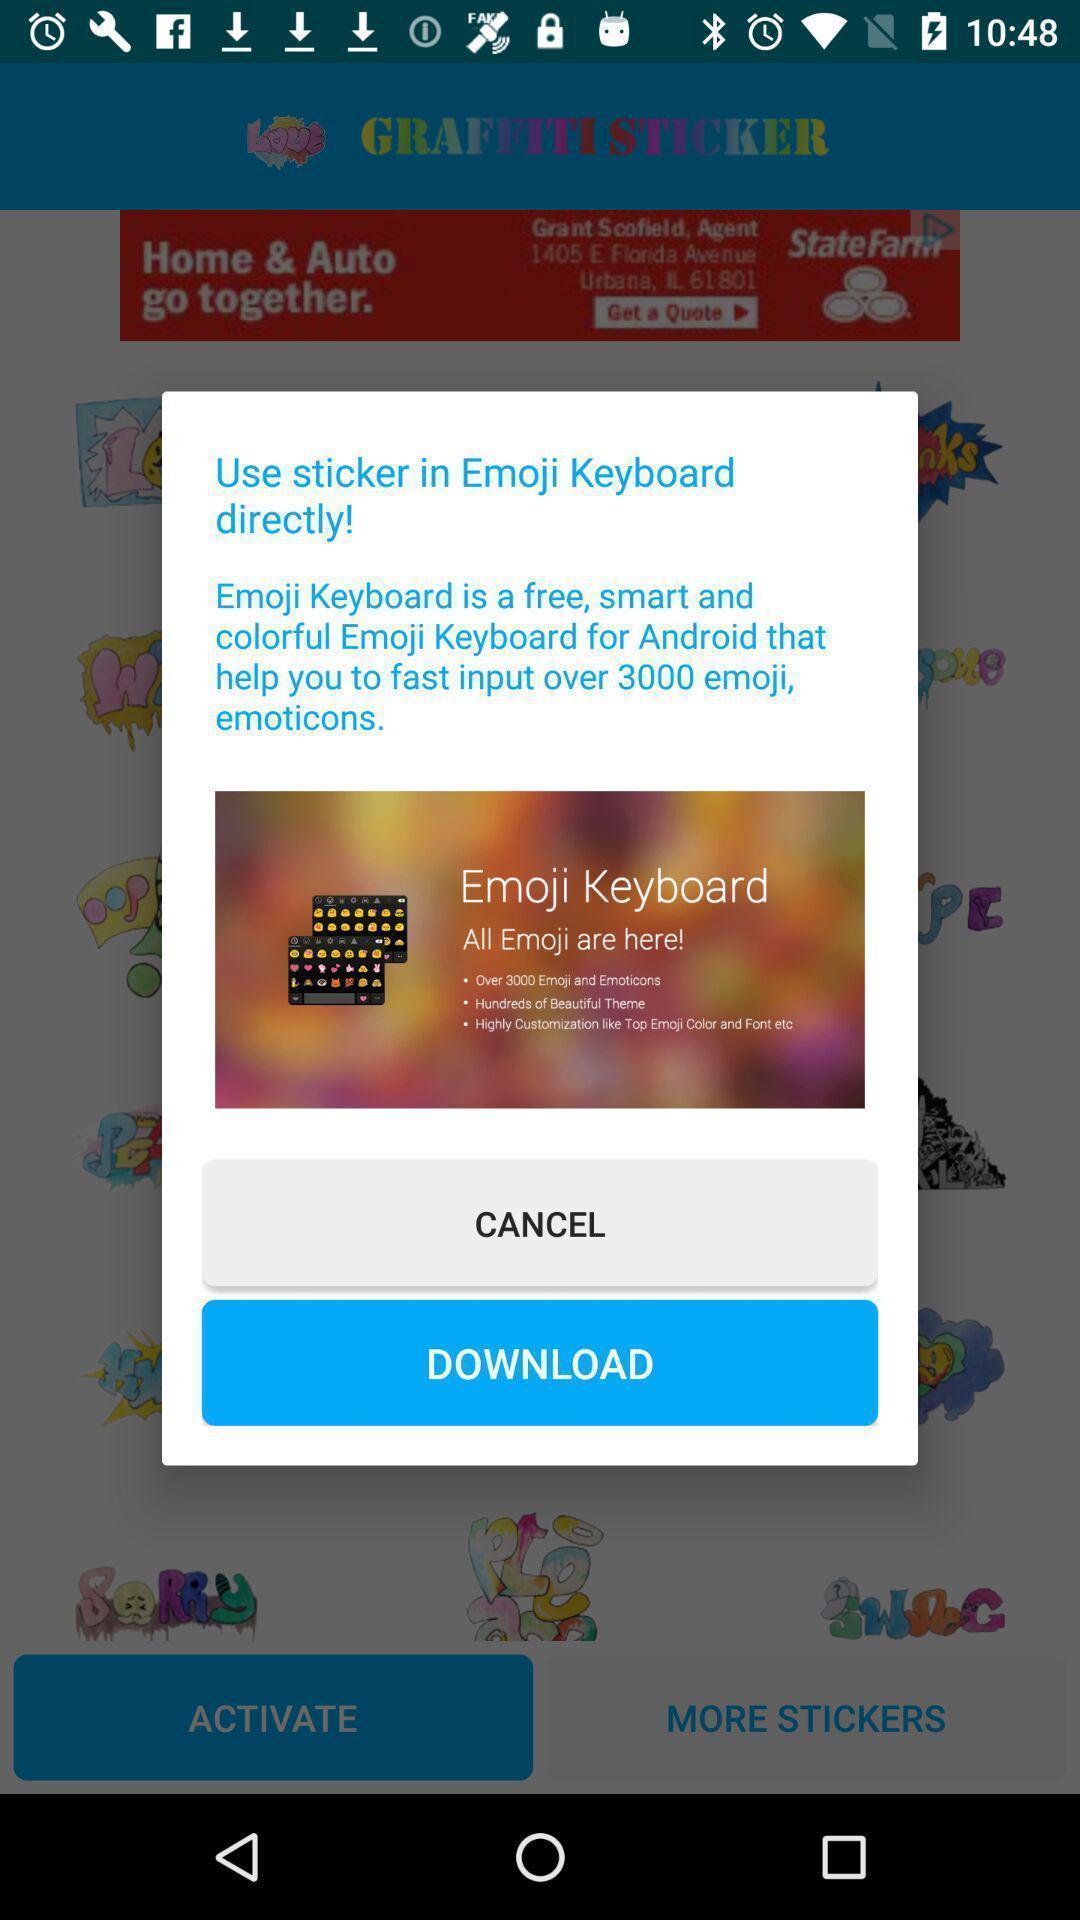Describe this image in words. Pop-up showing to download an application. 